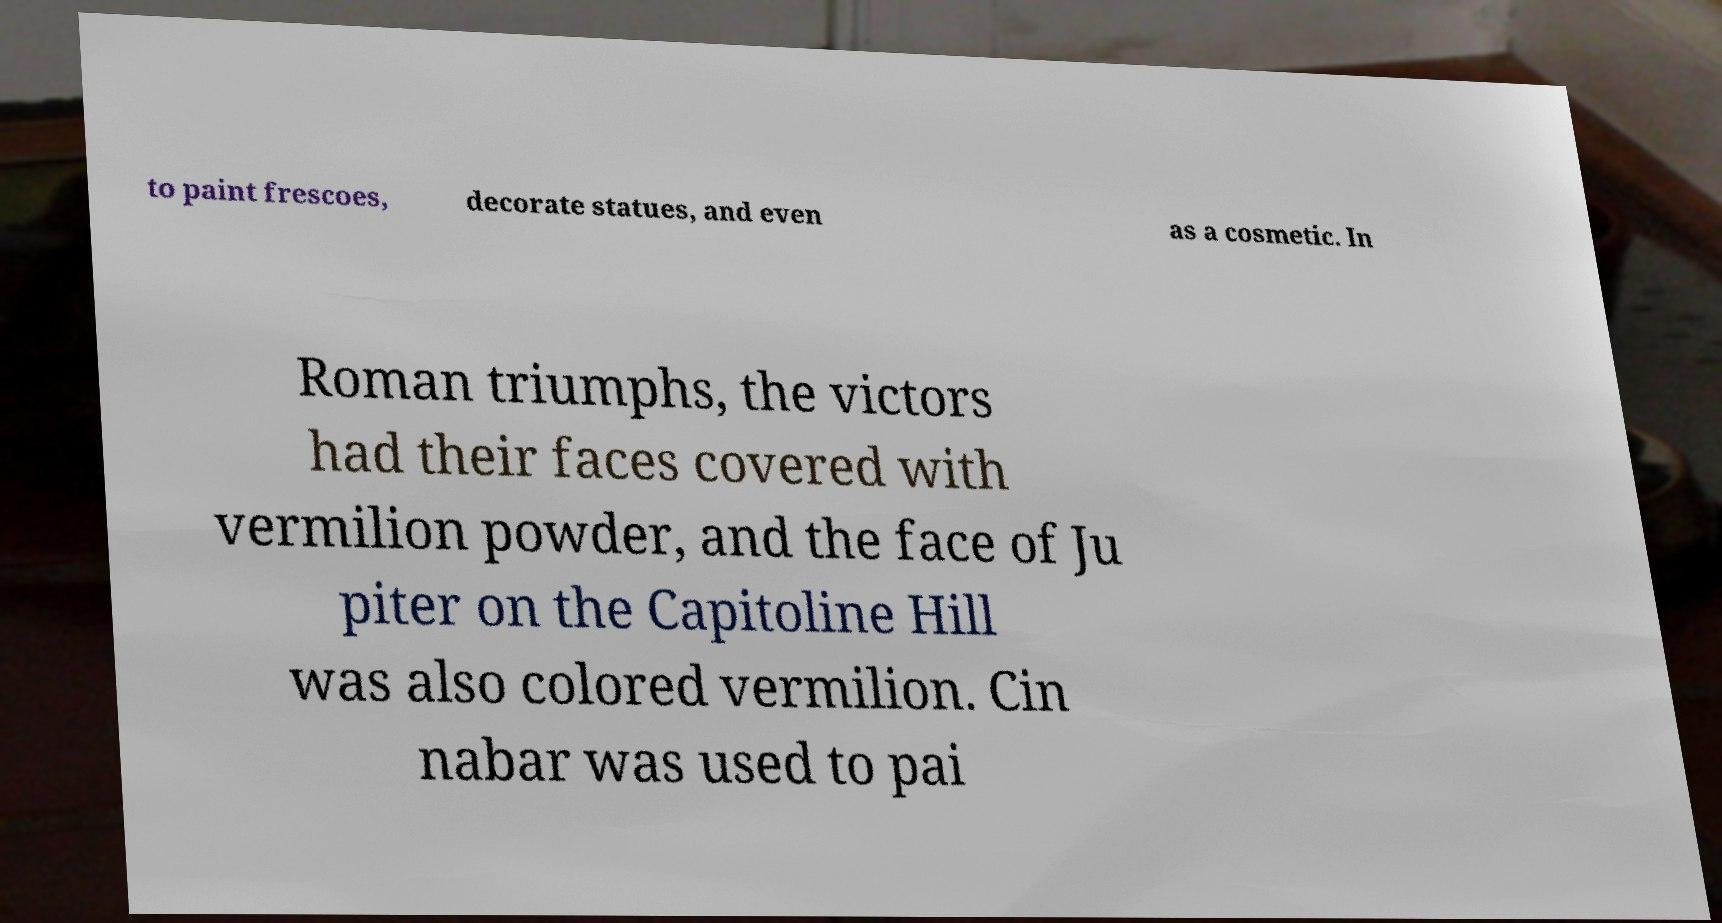What messages or text are displayed in this image? I need them in a readable, typed format. to paint frescoes, decorate statues, and even as a cosmetic. In Roman triumphs, the victors had their faces covered with vermilion powder, and the face of Ju piter on the Capitoline Hill was also colored vermilion. Cin nabar was used to pai 